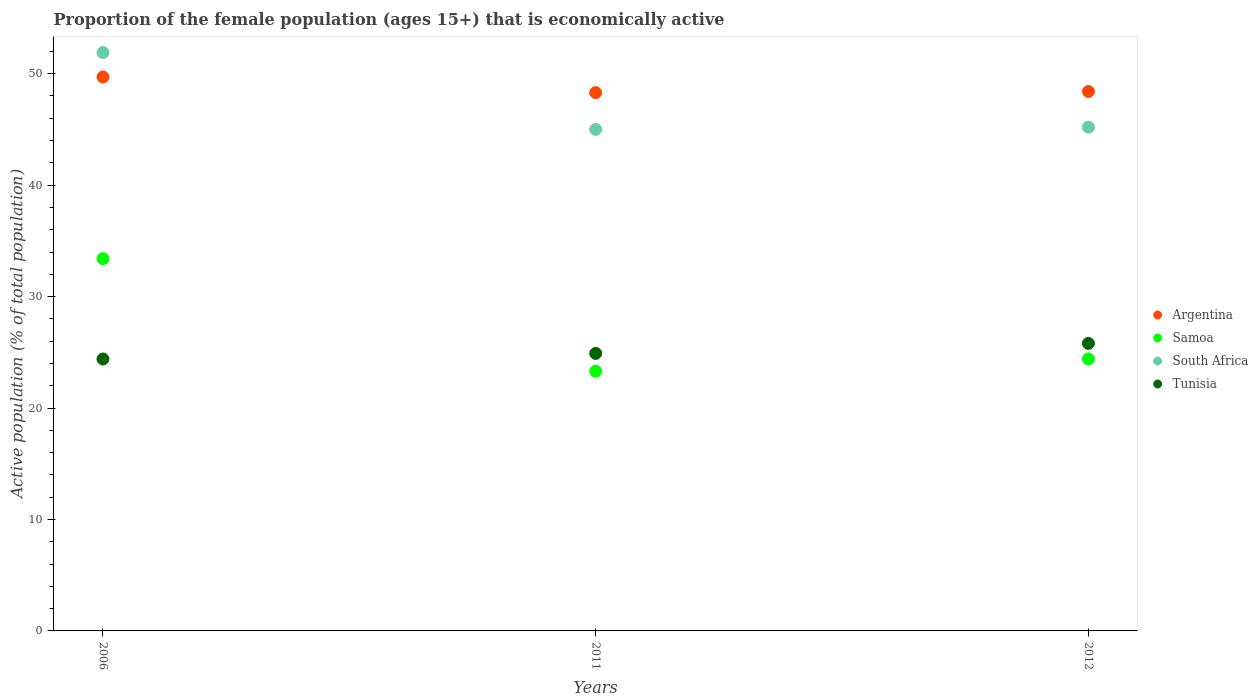How many different coloured dotlines are there?
Provide a succinct answer. 4. Is the number of dotlines equal to the number of legend labels?
Make the answer very short. Yes. What is the proportion of the female population that is economically active in Argentina in 2006?
Your response must be concise. 49.7. Across all years, what is the maximum proportion of the female population that is economically active in South Africa?
Provide a succinct answer. 51.9. Across all years, what is the minimum proportion of the female population that is economically active in South Africa?
Provide a succinct answer. 45. In which year was the proportion of the female population that is economically active in Samoa maximum?
Offer a terse response. 2006. In which year was the proportion of the female population that is economically active in Samoa minimum?
Provide a succinct answer. 2011. What is the total proportion of the female population that is economically active in Tunisia in the graph?
Make the answer very short. 75.1. What is the difference between the proportion of the female population that is economically active in Argentina in 2011 and that in 2012?
Your response must be concise. -0.1. What is the difference between the proportion of the female population that is economically active in Argentina in 2011 and the proportion of the female population that is economically active in South Africa in 2012?
Keep it short and to the point. 3.1. What is the average proportion of the female population that is economically active in Samoa per year?
Provide a short and direct response. 27.03. In the year 2012, what is the difference between the proportion of the female population that is economically active in South Africa and proportion of the female population that is economically active in Argentina?
Make the answer very short. -3.2. What is the ratio of the proportion of the female population that is economically active in Tunisia in 2011 to that in 2012?
Make the answer very short. 0.97. Is the proportion of the female population that is economically active in South Africa in 2006 less than that in 2012?
Keep it short and to the point. No. Is the difference between the proportion of the female population that is economically active in South Africa in 2011 and 2012 greater than the difference between the proportion of the female population that is economically active in Argentina in 2011 and 2012?
Offer a terse response. No. What is the difference between the highest and the second highest proportion of the female population that is economically active in Argentina?
Offer a terse response. 1.3. What is the difference between the highest and the lowest proportion of the female population that is economically active in Tunisia?
Make the answer very short. 1.4. Is it the case that in every year, the sum of the proportion of the female population that is economically active in Tunisia and proportion of the female population that is economically active in Samoa  is greater than the proportion of the female population that is economically active in South Africa?
Make the answer very short. Yes. Is the proportion of the female population that is economically active in Tunisia strictly greater than the proportion of the female population that is economically active in Argentina over the years?
Your response must be concise. No. Is the proportion of the female population that is economically active in Tunisia strictly less than the proportion of the female population that is economically active in Samoa over the years?
Your answer should be compact. No. How many years are there in the graph?
Provide a succinct answer. 3. Are the values on the major ticks of Y-axis written in scientific E-notation?
Offer a terse response. No. Where does the legend appear in the graph?
Give a very brief answer. Center right. What is the title of the graph?
Make the answer very short. Proportion of the female population (ages 15+) that is economically active. Does "East Asia (all income levels)" appear as one of the legend labels in the graph?
Provide a short and direct response. No. What is the label or title of the X-axis?
Your answer should be compact. Years. What is the label or title of the Y-axis?
Ensure brevity in your answer.  Active population (% of total population). What is the Active population (% of total population) in Argentina in 2006?
Your response must be concise. 49.7. What is the Active population (% of total population) of Samoa in 2006?
Your response must be concise. 33.4. What is the Active population (% of total population) in South Africa in 2006?
Provide a short and direct response. 51.9. What is the Active population (% of total population) in Tunisia in 2006?
Offer a terse response. 24.4. What is the Active population (% of total population) of Argentina in 2011?
Offer a terse response. 48.3. What is the Active population (% of total population) of Samoa in 2011?
Ensure brevity in your answer.  23.3. What is the Active population (% of total population) of South Africa in 2011?
Offer a very short reply. 45. What is the Active population (% of total population) of Tunisia in 2011?
Keep it short and to the point. 24.9. What is the Active population (% of total population) in Argentina in 2012?
Ensure brevity in your answer.  48.4. What is the Active population (% of total population) of Samoa in 2012?
Provide a succinct answer. 24.4. What is the Active population (% of total population) in South Africa in 2012?
Provide a short and direct response. 45.2. What is the Active population (% of total population) of Tunisia in 2012?
Your answer should be compact. 25.8. Across all years, what is the maximum Active population (% of total population) of Argentina?
Keep it short and to the point. 49.7. Across all years, what is the maximum Active population (% of total population) in Samoa?
Give a very brief answer. 33.4. Across all years, what is the maximum Active population (% of total population) in South Africa?
Your answer should be compact. 51.9. Across all years, what is the maximum Active population (% of total population) in Tunisia?
Provide a succinct answer. 25.8. Across all years, what is the minimum Active population (% of total population) of Argentina?
Ensure brevity in your answer.  48.3. Across all years, what is the minimum Active population (% of total population) of Samoa?
Offer a terse response. 23.3. Across all years, what is the minimum Active population (% of total population) of South Africa?
Offer a terse response. 45. Across all years, what is the minimum Active population (% of total population) of Tunisia?
Offer a very short reply. 24.4. What is the total Active population (% of total population) of Argentina in the graph?
Provide a short and direct response. 146.4. What is the total Active population (% of total population) of Samoa in the graph?
Keep it short and to the point. 81.1. What is the total Active population (% of total population) of South Africa in the graph?
Keep it short and to the point. 142.1. What is the total Active population (% of total population) in Tunisia in the graph?
Your answer should be compact. 75.1. What is the difference between the Active population (% of total population) in Samoa in 2006 and that in 2011?
Offer a terse response. 10.1. What is the difference between the Active population (% of total population) in Tunisia in 2006 and that in 2011?
Ensure brevity in your answer.  -0.5. What is the difference between the Active population (% of total population) of Argentina in 2006 and that in 2012?
Offer a very short reply. 1.3. What is the difference between the Active population (% of total population) of Samoa in 2006 and that in 2012?
Give a very brief answer. 9. What is the difference between the Active population (% of total population) of Tunisia in 2006 and that in 2012?
Offer a terse response. -1.4. What is the difference between the Active population (% of total population) in Argentina in 2011 and that in 2012?
Your response must be concise. -0.1. What is the difference between the Active population (% of total population) in South Africa in 2011 and that in 2012?
Offer a very short reply. -0.2. What is the difference between the Active population (% of total population) in Tunisia in 2011 and that in 2012?
Provide a succinct answer. -0.9. What is the difference between the Active population (% of total population) in Argentina in 2006 and the Active population (% of total population) in Samoa in 2011?
Offer a terse response. 26.4. What is the difference between the Active population (% of total population) in Argentina in 2006 and the Active population (% of total population) in South Africa in 2011?
Provide a succinct answer. 4.7. What is the difference between the Active population (% of total population) of Argentina in 2006 and the Active population (% of total population) of Tunisia in 2011?
Offer a terse response. 24.8. What is the difference between the Active population (% of total population) of Samoa in 2006 and the Active population (% of total population) of South Africa in 2011?
Keep it short and to the point. -11.6. What is the difference between the Active population (% of total population) of Samoa in 2006 and the Active population (% of total population) of Tunisia in 2011?
Offer a very short reply. 8.5. What is the difference between the Active population (% of total population) of Argentina in 2006 and the Active population (% of total population) of Samoa in 2012?
Provide a short and direct response. 25.3. What is the difference between the Active population (% of total population) of Argentina in 2006 and the Active population (% of total population) of Tunisia in 2012?
Keep it short and to the point. 23.9. What is the difference between the Active population (% of total population) in Samoa in 2006 and the Active population (% of total population) in South Africa in 2012?
Offer a very short reply. -11.8. What is the difference between the Active population (% of total population) of Samoa in 2006 and the Active population (% of total population) of Tunisia in 2012?
Keep it short and to the point. 7.6. What is the difference between the Active population (% of total population) in South Africa in 2006 and the Active population (% of total population) in Tunisia in 2012?
Make the answer very short. 26.1. What is the difference between the Active population (% of total population) of Argentina in 2011 and the Active population (% of total population) of Samoa in 2012?
Your answer should be compact. 23.9. What is the difference between the Active population (% of total population) of Argentina in 2011 and the Active population (% of total population) of South Africa in 2012?
Make the answer very short. 3.1. What is the difference between the Active population (% of total population) in Samoa in 2011 and the Active population (% of total population) in South Africa in 2012?
Provide a short and direct response. -21.9. What is the difference between the Active population (% of total population) in South Africa in 2011 and the Active population (% of total population) in Tunisia in 2012?
Provide a short and direct response. 19.2. What is the average Active population (% of total population) in Argentina per year?
Ensure brevity in your answer.  48.8. What is the average Active population (% of total population) in Samoa per year?
Provide a short and direct response. 27.03. What is the average Active population (% of total population) in South Africa per year?
Keep it short and to the point. 47.37. What is the average Active population (% of total population) of Tunisia per year?
Your answer should be very brief. 25.03. In the year 2006, what is the difference between the Active population (% of total population) in Argentina and Active population (% of total population) in Tunisia?
Your answer should be very brief. 25.3. In the year 2006, what is the difference between the Active population (% of total population) in Samoa and Active population (% of total population) in South Africa?
Give a very brief answer. -18.5. In the year 2006, what is the difference between the Active population (% of total population) of Samoa and Active population (% of total population) of Tunisia?
Your answer should be very brief. 9. In the year 2006, what is the difference between the Active population (% of total population) in South Africa and Active population (% of total population) in Tunisia?
Offer a terse response. 27.5. In the year 2011, what is the difference between the Active population (% of total population) of Argentina and Active population (% of total population) of Tunisia?
Offer a terse response. 23.4. In the year 2011, what is the difference between the Active population (% of total population) in Samoa and Active population (% of total population) in South Africa?
Make the answer very short. -21.7. In the year 2011, what is the difference between the Active population (% of total population) of South Africa and Active population (% of total population) of Tunisia?
Your answer should be very brief. 20.1. In the year 2012, what is the difference between the Active population (% of total population) of Argentina and Active population (% of total population) of Tunisia?
Your answer should be very brief. 22.6. In the year 2012, what is the difference between the Active population (% of total population) of Samoa and Active population (% of total population) of South Africa?
Offer a terse response. -20.8. What is the ratio of the Active population (% of total population) of Argentina in 2006 to that in 2011?
Give a very brief answer. 1.03. What is the ratio of the Active population (% of total population) of Samoa in 2006 to that in 2011?
Your response must be concise. 1.43. What is the ratio of the Active population (% of total population) of South Africa in 2006 to that in 2011?
Your answer should be very brief. 1.15. What is the ratio of the Active population (% of total population) of Tunisia in 2006 to that in 2011?
Give a very brief answer. 0.98. What is the ratio of the Active population (% of total population) in Argentina in 2006 to that in 2012?
Your response must be concise. 1.03. What is the ratio of the Active population (% of total population) in Samoa in 2006 to that in 2012?
Keep it short and to the point. 1.37. What is the ratio of the Active population (% of total population) of South Africa in 2006 to that in 2012?
Offer a terse response. 1.15. What is the ratio of the Active population (% of total population) in Tunisia in 2006 to that in 2012?
Offer a terse response. 0.95. What is the ratio of the Active population (% of total population) of Samoa in 2011 to that in 2012?
Offer a very short reply. 0.95. What is the ratio of the Active population (% of total population) in Tunisia in 2011 to that in 2012?
Provide a short and direct response. 0.97. What is the difference between the highest and the second highest Active population (% of total population) in Argentina?
Your answer should be compact. 1.3. What is the difference between the highest and the second highest Active population (% of total population) in Samoa?
Your response must be concise. 9. What is the difference between the highest and the second highest Active population (% of total population) in Tunisia?
Give a very brief answer. 0.9. What is the difference between the highest and the lowest Active population (% of total population) in Samoa?
Ensure brevity in your answer.  10.1. What is the difference between the highest and the lowest Active population (% of total population) of South Africa?
Ensure brevity in your answer.  6.9. What is the difference between the highest and the lowest Active population (% of total population) in Tunisia?
Keep it short and to the point. 1.4. 